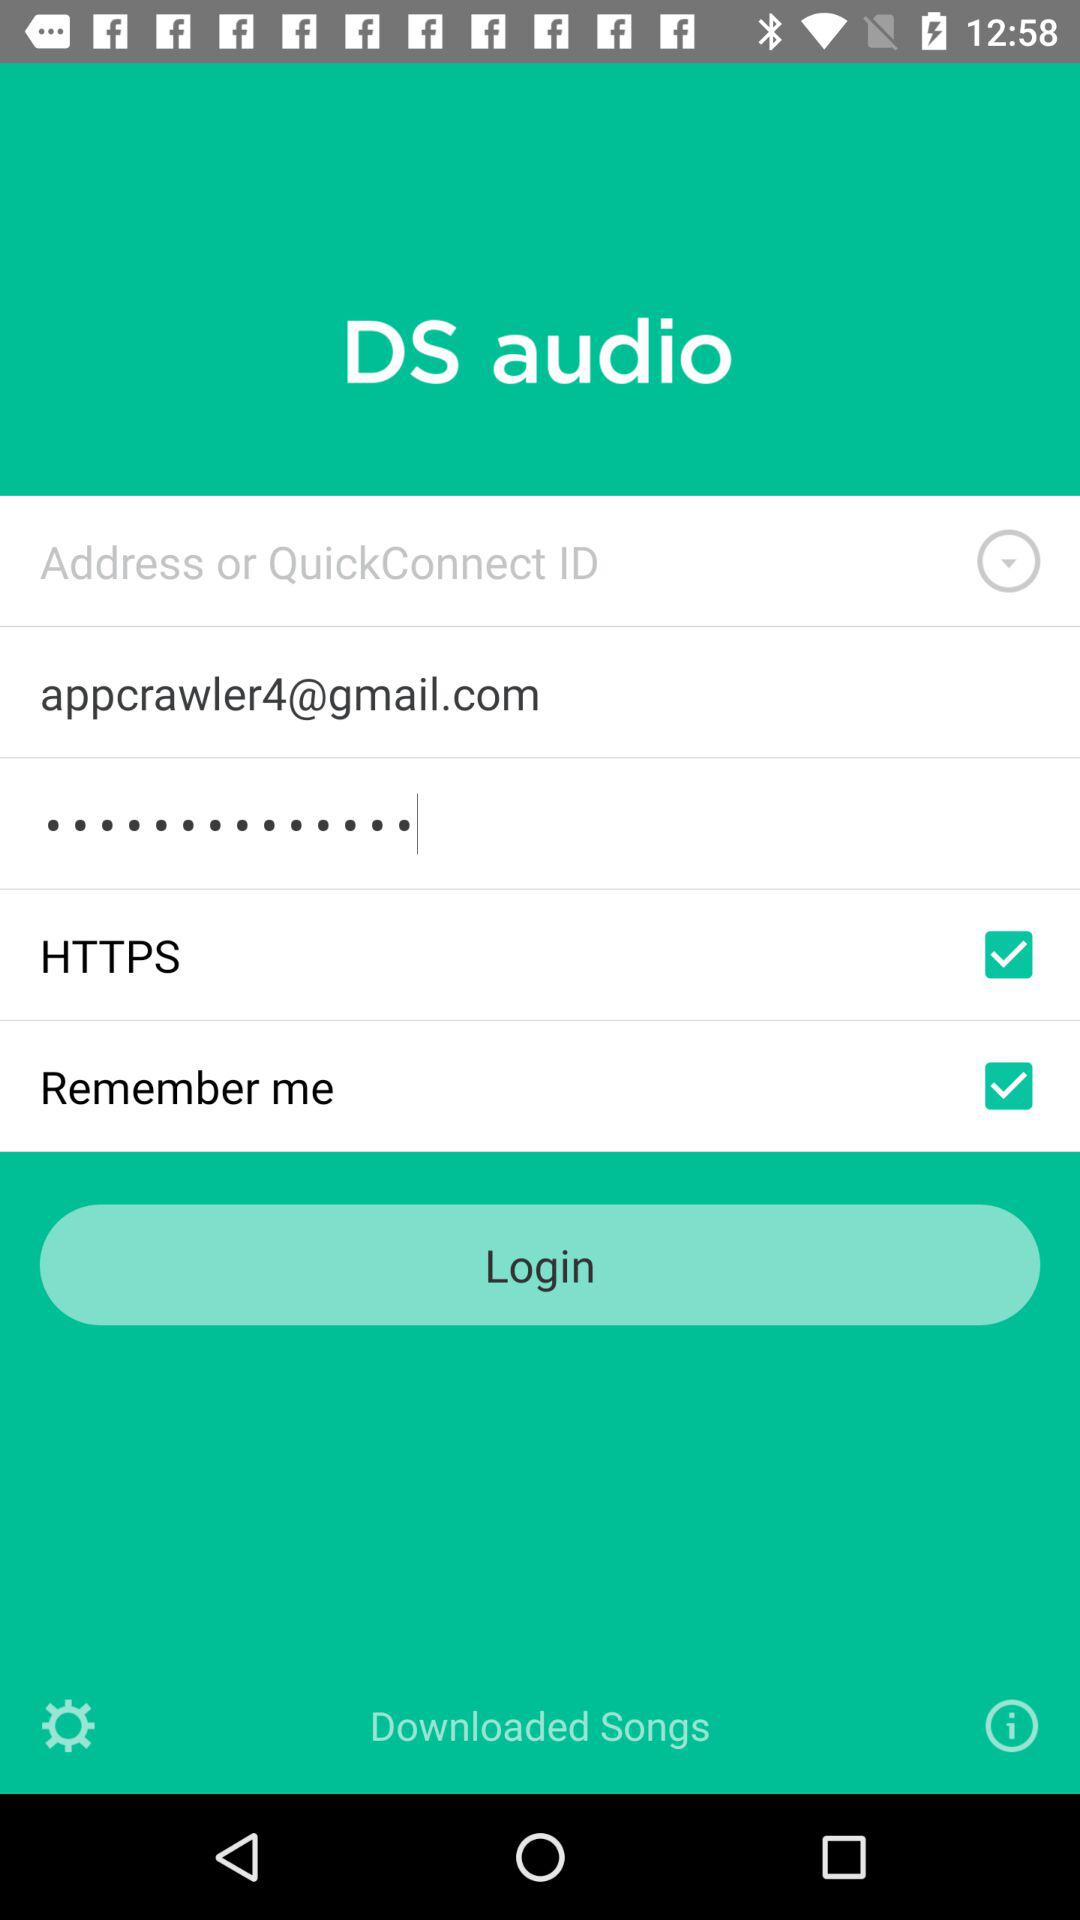What is the email address of the user? The email address is appcrawler4@gmail.com. 